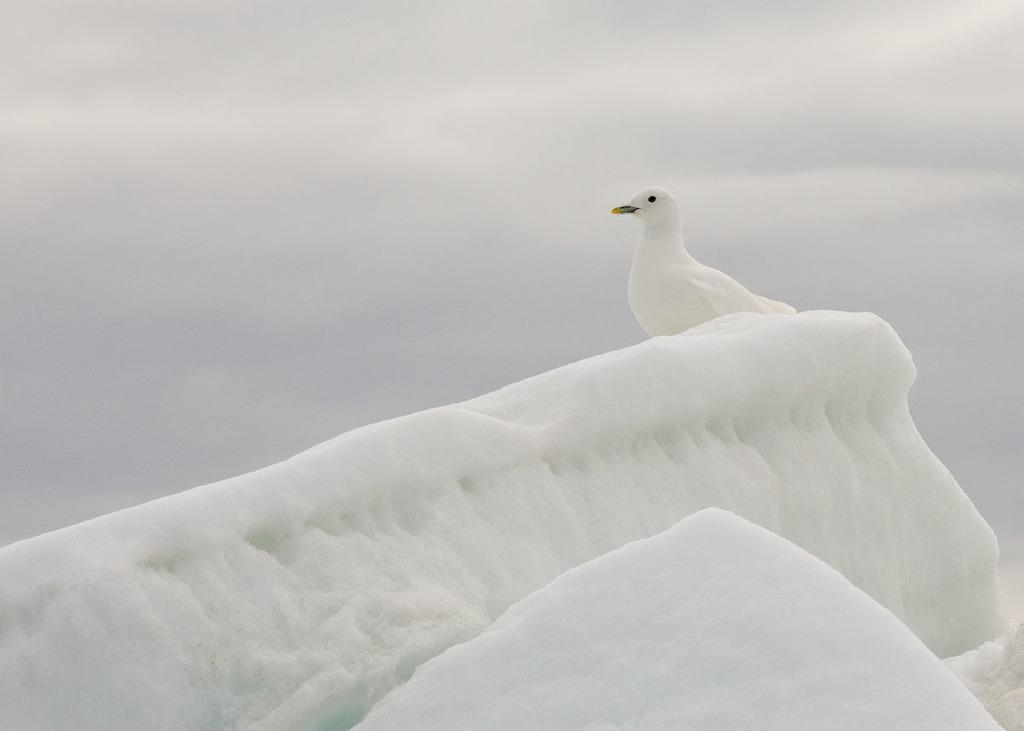Please provide a concise description of this image. In the image we can see the white pigeon, snow and the cloudy sky. 